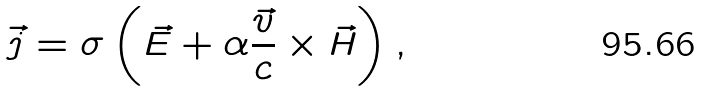<formula> <loc_0><loc_0><loc_500><loc_500>\vec { j } = \sigma \left ( \vec { E } + \alpha \frac { \vec { v } } { c } \times \vec { H } \right ) ,</formula> 